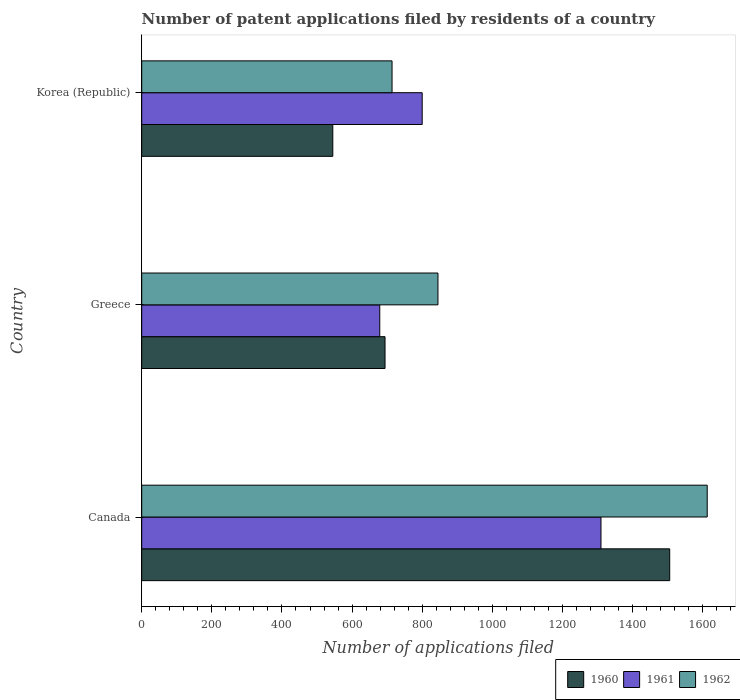How many different coloured bars are there?
Make the answer very short. 3. Are the number of bars per tick equal to the number of legend labels?
Give a very brief answer. Yes. Are the number of bars on each tick of the Y-axis equal?
Your response must be concise. Yes. In how many cases, is the number of bars for a given country not equal to the number of legend labels?
Provide a short and direct response. 0. What is the number of applications filed in 1960 in Korea (Republic)?
Offer a very short reply. 545. Across all countries, what is the maximum number of applications filed in 1962?
Give a very brief answer. 1613. Across all countries, what is the minimum number of applications filed in 1962?
Offer a terse response. 714. In which country was the number of applications filed in 1962 maximum?
Ensure brevity in your answer.  Canada. What is the total number of applications filed in 1961 in the graph?
Give a very brief answer. 2789. What is the difference between the number of applications filed in 1962 in Canada and that in Greece?
Provide a short and direct response. 768. What is the difference between the number of applications filed in 1961 in Greece and the number of applications filed in 1962 in Canada?
Provide a short and direct response. -934. What is the average number of applications filed in 1961 per country?
Offer a terse response. 929.67. In how many countries, is the number of applications filed in 1962 greater than 80 ?
Offer a very short reply. 3. What is the ratio of the number of applications filed in 1961 in Canada to that in Greece?
Provide a short and direct response. 1.93. Is the number of applications filed in 1960 in Canada less than that in Greece?
Provide a succinct answer. No. What is the difference between the highest and the second highest number of applications filed in 1962?
Provide a short and direct response. 768. What is the difference between the highest and the lowest number of applications filed in 1962?
Your answer should be very brief. 899. In how many countries, is the number of applications filed in 1960 greater than the average number of applications filed in 1960 taken over all countries?
Keep it short and to the point. 1. Is the sum of the number of applications filed in 1962 in Canada and Korea (Republic) greater than the maximum number of applications filed in 1961 across all countries?
Give a very brief answer. Yes. Is it the case that in every country, the sum of the number of applications filed in 1961 and number of applications filed in 1960 is greater than the number of applications filed in 1962?
Your answer should be compact. Yes. How many bars are there?
Offer a terse response. 9. Are all the bars in the graph horizontal?
Offer a very short reply. Yes. Does the graph contain any zero values?
Offer a terse response. No. Does the graph contain grids?
Keep it short and to the point. No. Where does the legend appear in the graph?
Your answer should be very brief. Bottom right. How many legend labels are there?
Provide a succinct answer. 3. How are the legend labels stacked?
Your answer should be compact. Horizontal. What is the title of the graph?
Offer a very short reply. Number of patent applications filed by residents of a country. What is the label or title of the X-axis?
Your response must be concise. Number of applications filed. What is the label or title of the Y-axis?
Make the answer very short. Country. What is the Number of applications filed of 1960 in Canada?
Make the answer very short. 1506. What is the Number of applications filed of 1961 in Canada?
Provide a short and direct response. 1310. What is the Number of applications filed in 1962 in Canada?
Your response must be concise. 1613. What is the Number of applications filed in 1960 in Greece?
Keep it short and to the point. 694. What is the Number of applications filed in 1961 in Greece?
Your response must be concise. 679. What is the Number of applications filed in 1962 in Greece?
Your answer should be very brief. 845. What is the Number of applications filed in 1960 in Korea (Republic)?
Your answer should be compact. 545. What is the Number of applications filed in 1961 in Korea (Republic)?
Provide a succinct answer. 800. What is the Number of applications filed of 1962 in Korea (Republic)?
Ensure brevity in your answer.  714. Across all countries, what is the maximum Number of applications filed in 1960?
Your response must be concise. 1506. Across all countries, what is the maximum Number of applications filed in 1961?
Give a very brief answer. 1310. Across all countries, what is the maximum Number of applications filed of 1962?
Your answer should be compact. 1613. Across all countries, what is the minimum Number of applications filed of 1960?
Provide a succinct answer. 545. Across all countries, what is the minimum Number of applications filed of 1961?
Offer a very short reply. 679. Across all countries, what is the minimum Number of applications filed of 1962?
Offer a terse response. 714. What is the total Number of applications filed in 1960 in the graph?
Your response must be concise. 2745. What is the total Number of applications filed in 1961 in the graph?
Offer a terse response. 2789. What is the total Number of applications filed in 1962 in the graph?
Make the answer very short. 3172. What is the difference between the Number of applications filed in 1960 in Canada and that in Greece?
Offer a terse response. 812. What is the difference between the Number of applications filed in 1961 in Canada and that in Greece?
Provide a succinct answer. 631. What is the difference between the Number of applications filed in 1962 in Canada and that in Greece?
Your answer should be very brief. 768. What is the difference between the Number of applications filed of 1960 in Canada and that in Korea (Republic)?
Your answer should be very brief. 961. What is the difference between the Number of applications filed of 1961 in Canada and that in Korea (Republic)?
Your response must be concise. 510. What is the difference between the Number of applications filed of 1962 in Canada and that in Korea (Republic)?
Your answer should be very brief. 899. What is the difference between the Number of applications filed in 1960 in Greece and that in Korea (Republic)?
Your answer should be compact. 149. What is the difference between the Number of applications filed in 1961 in Greece and that in Korea (Republic)?
Make the answer very short. -121. What is the difference between the Number of applications filed in 1962 in Greece and that in Korea (Republic)?
Provide a succinct answer. 131. What is the difference between the Number of applications filed of 1960 in Canada and the Number of applications filed of 1961 in Greece?
Provide a succinct answer. 827. What is the difference between the Number of applications filed in 1960 in Canada and the Number of applications filed in 1962 in Greece?
Your answer should be very brief. 661. What is the difference between the Number of applications filed of 1961 in Canada and the Number of applications filed of 1962 in Greece?
Give a very brief answer. 465. What is the difference between the Number of applications filed of 1960 in Canada and the Number of applications filed of 1961 in Korea (Republic)?
Offer a terse response. 706. What is the difference between the Number of applications filed of 1960 in Canada and the Number of applications filed of 1962 in Korea (Republic)?
Give a very brief answer. 792. What is the difference between the Number of applications filed of 1961 in Canada and the Number of applications filed of 1962 in Korea (Republic)?
Offer a terse response. 596. What is the difference between the Number of applications filed in 1960 in Greece and the Number of applications filed in 1961 in Korea (Republic)?
Ensure brevity in your answer.  -106. What is the difference between the Number of applications filed in 1960 in Greece and the Number of applications filed in 1962 in Korea (Republic)?
Offer a terse response. -20. What is the difference between the Number of applications filed of 1961 in Greece and the Number of applications filed of 1962 in Korea (Republic)?
Offer a very short reply. -35. What is the average Number of applications filed of 1960 per country?
Keep it short and to the point. 915. What is the average Number of applications filed of 1961 per country?
Ensure brevity in your answer.  929.67. What is the average Number of applications filed in 1962 per country?
Keep it short and to the point. 1057.33. What is the difference between the Number of applications filed in 1960 and Number of applications filed in 1961 in Canada?
Provide a short and direct response. 196. What is the difference between the Number of applications filed of 1960 and Number of applications filed of 1962 in Canada?
Keep it short and to the point. -107. What is the difference between the Number of applications filed of 1961 and Number of applications filed of 1962 in Canada?
Provide a short and direct response. -303. What is the difference between the Number of applications filed in 1960 and Number of applications filed in 1961 in Greece?
Offer a terse response. 15. What is the difference between the Number of applications filed in 1960 and Number of applications filed in 1962 in Greece?
Ensure brevity in your answer.  -151. What is the difference between the Number of applications filed of 1961 and Number of applications filed of 1962 in Greece?
Your answer should be compact. -166. What is the difference between the Number of applications filed in 1960 and Number of applications filed in 1961 in Korea (Republic)?
Ensure brevity in your answer.  -255. What is the difference between the Number of applications filed in 1960 and Number of applications filed in 1962 in Korea (Republic)?
Offer a very short reply. -169. What is the ratio of the Number of applications filed of 1960 in Canada to that in Greece?
Your answer should be very brief. 2.17. What is the ratio of the Number of applications filed of 1961 in Canada to that in Greece?
Offer a very short reply. 1.93. What is the ratio of the Number of applications filed of 1962 in Canada to that in Greece?
Make the answer very short. 1.91. What is the ratio of the Number of applications filed in 1960 in Canada to that in Korea (Republic)?
Your response must be concise. 2.76. What is the ratio of the Number of applications filed of 1961 in Canada to that in Korea (Republic)?
Your response must be concise. 1.64. What is the ratio of the Number of applications filed in 1962 in Canada to that in Korea (Republic)?
Your answer should be very brief. 2.26. What is the ratio of the Number of applications filed in 1960 in Greece to that in Korea (Republic)?
Ensure brevity in your answer.  1.27. What is the ratio of the Number of applications filed in 1961 in Greece to that in Korea (Republic)?
Give a very brief answer. 0.85. What is the ratio of the Number of applications filed of 1962 in Greece to that in Korea (Republic)?
Your response must be concise. 1.18. What is the difference between the highest and the second highest Number of applications filed in 1960?
Ensure brevity in your answer.  812. What is the difference between the highest and the second highest Number of applications filed of 1961?
Offer a terse response. 510. What is the difference between the highest and the second highest Number of applications filed of 1962?
Offer a terse response. 768. What is the difference between the highest and the lowest Number of applications filed of 1960?
Your response must be concise. 961. What is the difference between the highest and the lowest Number of applications filed in 1961?
Give a very brief answer. 631. What is the difference between the highest and the lowest Number of applications filed of 1962?
Offer a very short reply. 899. 